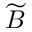<formula> <loc_0><loc_0><loc_500><loc_500>\widetilde { B }</formula> 